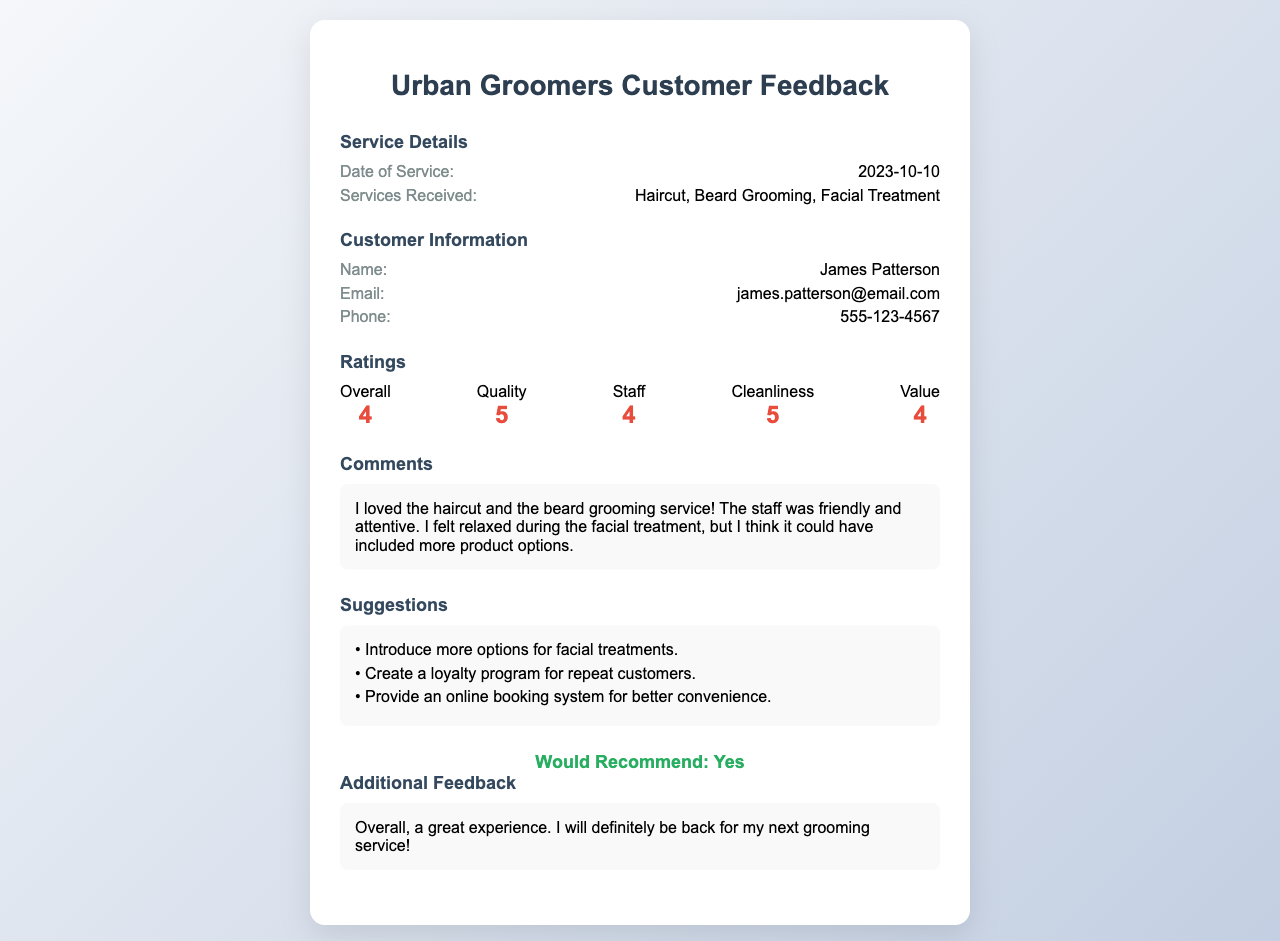What is the name of the customer? The customer's name is listed under Customer Information in the document.
Answer: James Patterson What services did the customer receive? The services received are detailed under Service Details in the document.
Answer: Haircut, Beard Grooming, Facial Treatment When was the service performed? The date of service is specified in the Service Details section.
Answer: 2023-10-10 What was the rating for Quality? The rating for Quality can be found in the Ratings section of the document.
Answer: 5 What suggestion did the customer provide regarding facial treatments? The suggestion can be found in the Suggestions section of the document.
Answer: Introduce more options for facial treatments What was the overall recommendation from the customer? The recommendation is stated in the document, indicating the customer's willingness to recommend the service.
Answer: Yes How many suggestions were provided by the customer? The number of suggestions is determined by counting the entries in the Suggestions section.
Answer: 3 What rating did the customer give for Cleanliness? The rating for Cleanliness is part of the Ratings section and is explicitly mentioned.
Answer: 5 What email address did the customer provide? The email address can be found under Customer Information in the document.
Answer: james.patterson@email.com 